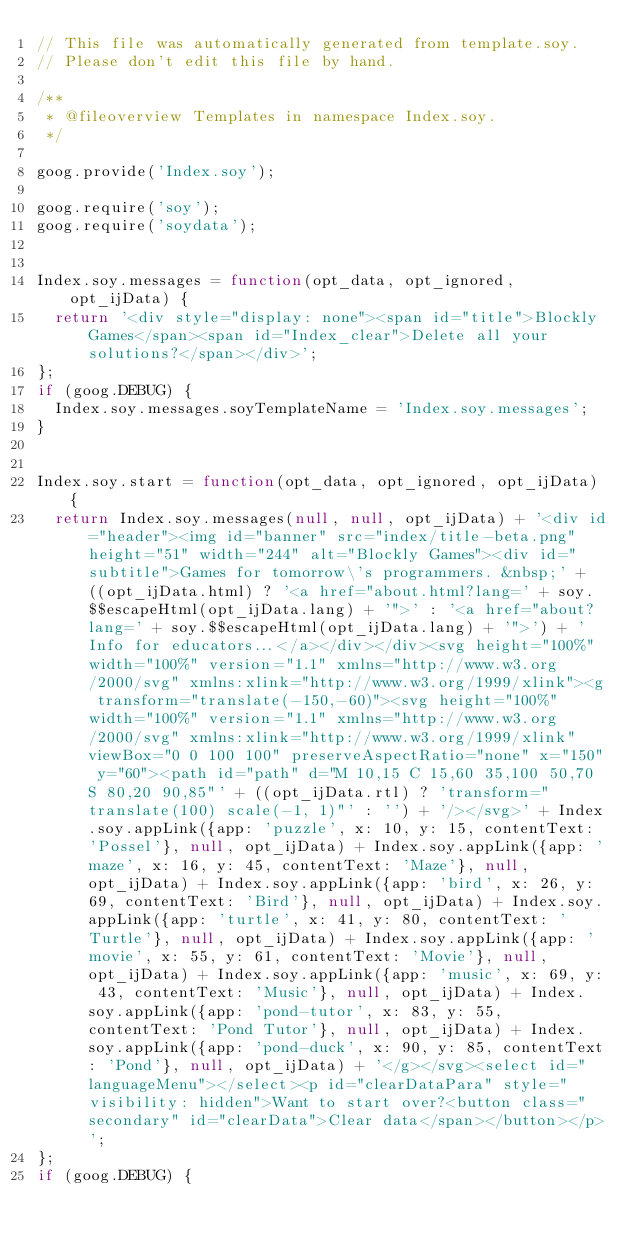Convert code to text. <code><loc_0><loc_0><loc_500><loc_500><_JavaScript_>// This file was automatically generated from template.soy.
// Please don't edit this file by hand.

/**
 * @fileoverview Templates in namespace Index.soy.
 */

goog.provide('Index.soy');

goog.require('soy');
goog.require('soydata');


Index.soy.messages = function(opt_data, opt_ignored, opt_ijData) {
  return '<div style="display: none"><span id="title">Blockly Games</span><span id="Index_clear">Delete all your solutions?</span></div>';
};
if (goog.DEBUG) {
  Index.soy.messages.soyTemplateName = 'Index.soy.messages';
}


Index.soy.start = function(opt_data, opt_ignored, opt_ijData) {
  return Index.soy.messages(null, null, opt_ijData) + '<div id="header"><img id="banner" src="index/title-beta.png" height="51" width="244" alt="Blockly Games"><div id="subtitle">Games for tomorrow\'s programmers. &nbsp;' + ((opt_ijData.html) ? '<a href="about.html?lang=' + soy.$$escapeHtml(opt_ijData.lang) + '">' : '<a href="about?lang=' + soy.$$escapeHtml(opt_ijData.lang) + '">') + 'Info for educators...</a></div></div><svg height="100%" width="100%" version="1.1" xmlns="http://www.w3.org/2000/svg" xmlns:xlink="http://www.w3.org/1999/xlink"><g transform="translate(-150,-60)"><svg height="100%" width="100%" version="1.1" xmlns="http://www.w3.org/2000/svg" xmlns:xlink="http://www.w3.org/1999/xlink" viewBox="0 0 100 100" preserveAspectRatio="none" x="150" y="60"><path id="path" d="M 10,15 C 15,60 35,100 50,70 S 80,20 90,85"' + ((opt_ijData.rtl) ? 'transform="translate(100) scale(-1, 1)"' : '') + '/></svg>' + Index.soy.appLink({app: 'puzzle', x: 10, y: 15, contentText: 'Possel'}, null, opt_ijData) + Index.soy.appLink({app: 'maze', x: 16, y: 45, contentText: 'Maze'}, null, opt_ijData) + Index.soy.appLink({app: 'bird', x: 26, y: 69, contentText: 'Bird'}, null, opt_ijData) + Index.soy.appLink({app: 'turtle', x: 41, y: 80, contentText: 'Turtle'}, null, opt_ijData) + Index.soy.appLink({app: 'movie', x: 55, y: 61, contentText: 'Movie'}, null, opt_ijData) + Index.soy.appLink({app: 'music', x: 69, y: 43, contentText: 'Music'}, null, opt_ijData) + Index.soy.appLink({app: 'pond-tutor', x: 83, y: 55, contentText: 'Pond Tutor'}, null, opt_ijData) + Index.soy.appLink({app: 'pond-duck', x: 90, y: 85, contentText: 'Pond'}, null, opt_ijData) + '</g></svg><select id="languageMenu"></select><p id="clearDataPara" style="visibility: hidden">Want to start over?<button class="secondary" id="clearData">Clear data</span></button></p>';
};
if (goog.DEBUG) {</code> 